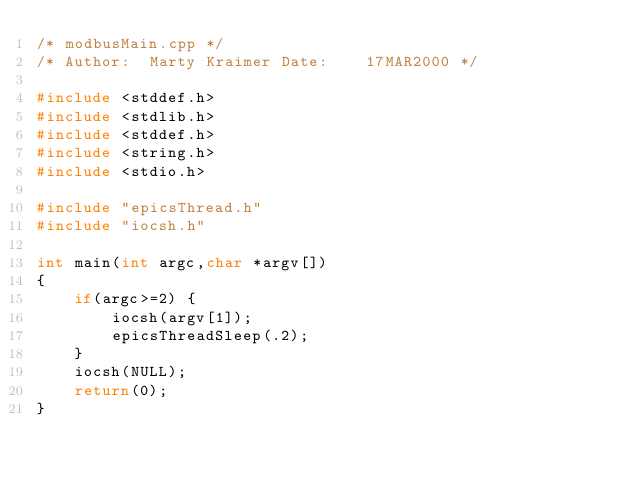Convert code to text. <code><loc_0><loc_0><loc_500><loc_500><_C++_>/* modbusMain.cpp */
/* Author:  Marty Kraimer Date:    17MAR2000 */

#include <stddef.h>
#include <stdlib.h>
#include <stddef.h>
#include <string.h>
#include <stdio.h>

#include "epicsThread.h"
#include "iocsh.h"

int main(int argc,char *argv[])
{
    if(argc>=2) { 
        iocsh(argv[1]);
        epicsThreadSleep(.2);
    }
    iocsh(NULL);
    return(0);
}
</code> 